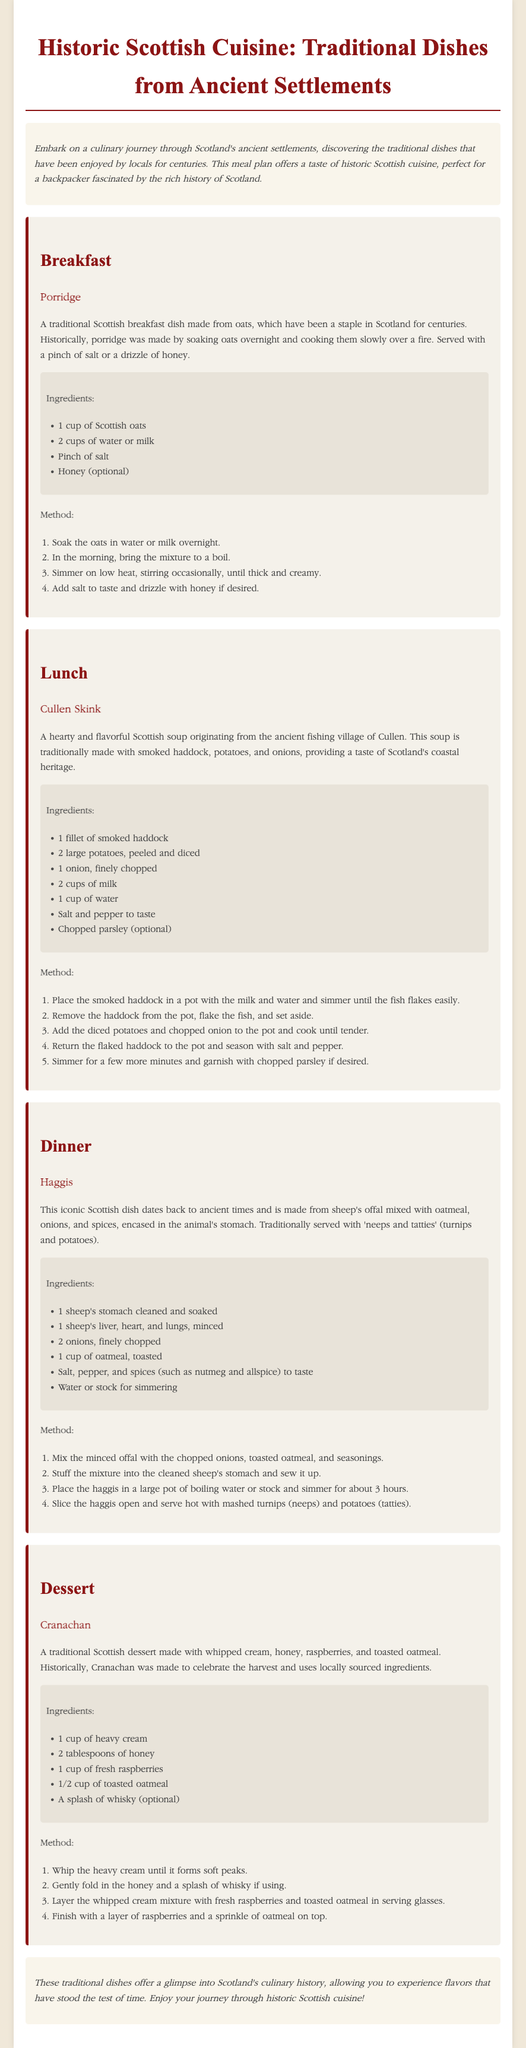What is a traditional Scottish breakfast dish? The traditional Scottish breakfast dish mentioned in the document is porridge.
Answer: porridge How many cups of Scottish oats are needed for porridge? The document states that 1 cup of Scottish oats is needed for porridge.
Answer: 1 cup What are the main ingredients in Cullen Skink? The main ingredients listed for Cullen Skink are smoked haddock, potatoes, and onions.
Answer: smoked haddock, potatoes, onions What key ingredient is traditionally served with haggis? The traditional ingredient served with haggis is neeps and tatties.
Answer: neeps and tatties What type of cream is used in Cranachan? The type of cream used in Cranachan is heavy cream.
Answer: heavy cream How long should haggis be simmered? The document indicates that haggis should be simmered for about 3 hours.
Answer: 3 hours What historical origin does Cullen Skink have? Cullen Skink originates from the ancient fishing village of Cullen.
Answer: Cullen Which meal features a dessert? The dessert is featured in the dinner meal section of the document.
Answer: dessert What optional ingredient can be added to Cranachan? The optional ingredient mentioned for Cranachan is whisky.
Answer: whisky 